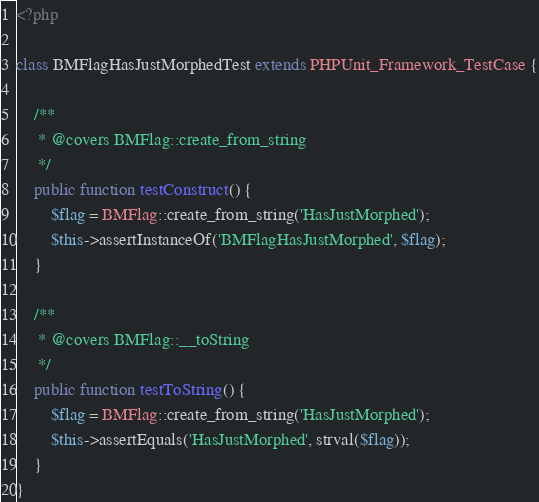<code> <loc_0><loc_0><loc_500><loc_500><_PHP_><?php

class BMFlagHasJustMorphedTest extends PHPUnit_Framework_TestCase {

    /**
     * @covers BMFlag::create_from_string
     */
    public function testConstruct() {
        $flag = BMFlag::create_from_string('HasJustMorphed');
        $this->assertInstanceOf('BMFlagHasJustMorphed', $flag);
    }

    /**
     * @covers BMFlag::__toString
     */
    public function testToString() {
        $flag = BMFlag::create_from_string('HasJustMorphed');
        $this->assertEquals('HasJustMorphed', strval($flag));
    }
}
</code> 